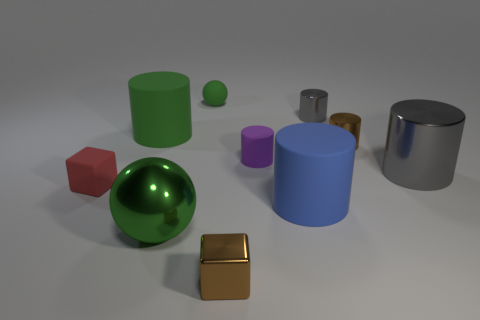Subtract all purple matte cylinders. How many cylinders are left? 5 Subtract all blue cylinders. How many cylinders are left? 5 Subtract 2 cubes. How many cubes are left? 0 Subtract all balls. How many objects are left? 8 Add 1 big matte cylinders. How many big matte cylinders are left? 3 Add 1 big gray rubber cubes. How many big gray rubber cubes exist? 1 Subtract 1 purple cylinders. How many objects are left? 9 Subtract all green cylinders. Subtract all blue spheres. How many cylinders are left? 5 Subtract all blue spheres. How many brown cubes are left? 1 Subtract all brown balls. Subtract all large green cylinders. How many objects are left? 9 